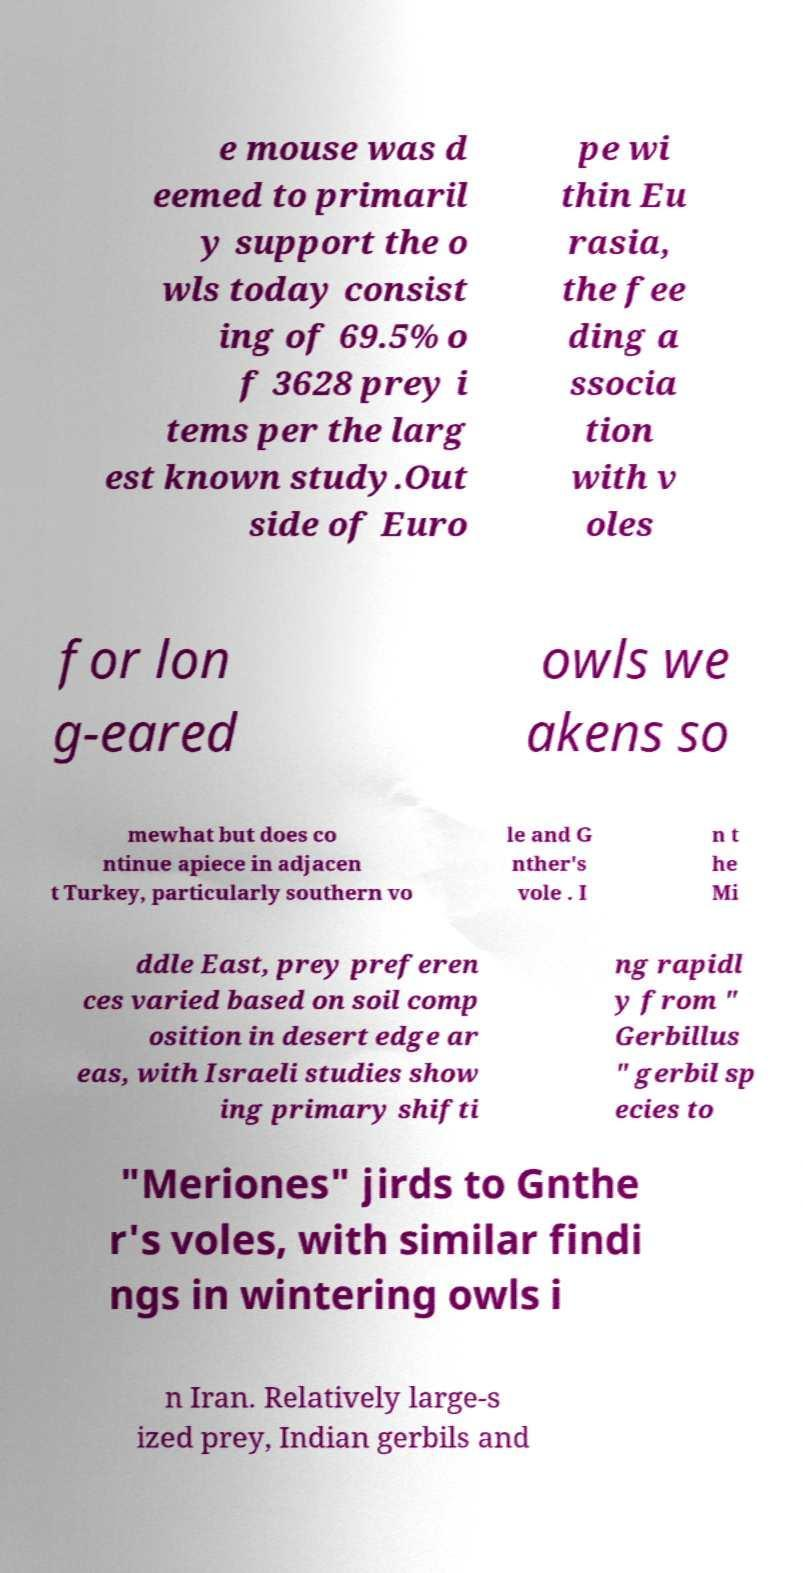Can you read and provide the text displayed in the image?This photo seems to have some interesting text. Can you extract and type it out for me? e mouse was d eemed to primaril y support the o wls today consist ing of 69.5% o f 3628 prey i tems per the larg est known study.Out side of Euro pe wi thin Eu rasia, the fee ding a ssocia tion with v oles for lon g-eared owls we akens so mewhat but does co ntinue apiece in adjacen t Turkey, particularly southern vo le and G nther's vole . I n t he Mi ddle East, prey preferen ces varied based on soil comp osition in desert edge ar eas, with Israeli studies show ing primary shifti ng rapidl y from " Gerbillus " gerbil sp ecies to "Meriones" jirds to Gnthe r's voles, with similar findi ngs in wintering owls i n Iran. Relatively large-s ized prey, Indian gerbils and 